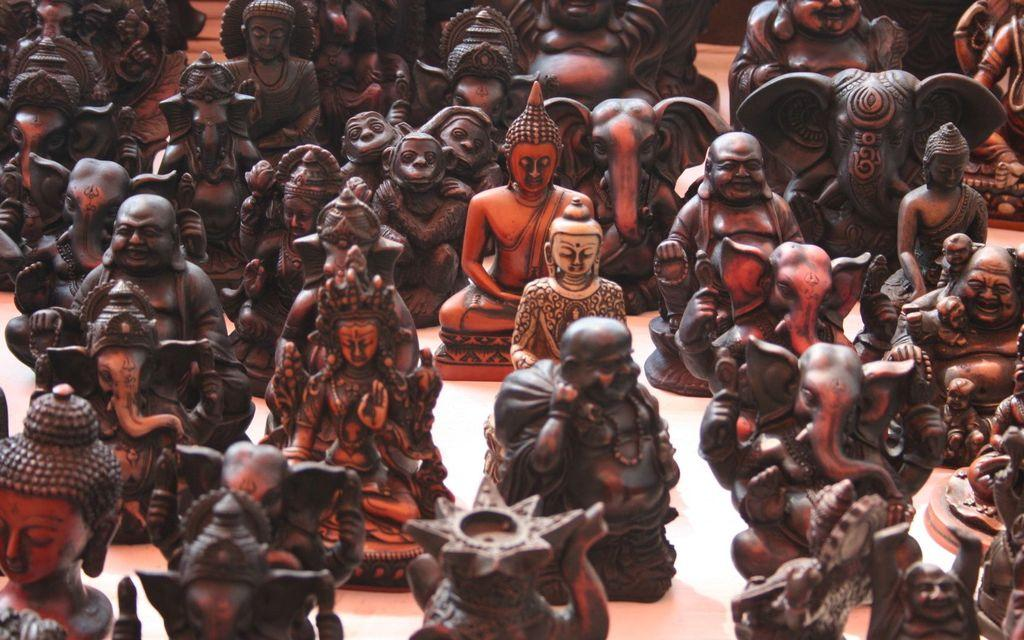What type of objects can be seen in the image? There are sculptures in the image. Where are the sculptures located? The sculptures are on a table. What type of metal is the beef sculpture made of in the image? There is no beef sculpture present in the image, and therefore no such material can be identified. 